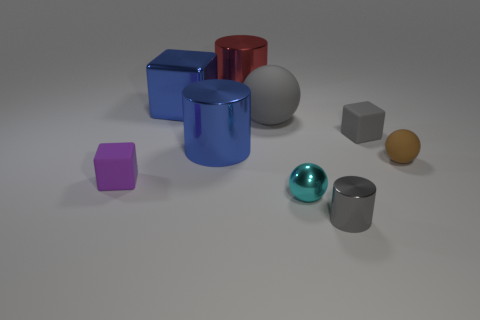Subtract all big blue cylinders. How many cylinders are left? 2 Add 1 purple shiny spheres. How many objects exist? 10 Subtract all spheres. How many objects are left? 6 Subtract all red balls. Subtract all cyan blocks. How many balls are left? 3 Add 5 gray cylinders. How many gray cylinders exist? 6 Subtract 1 blue cylinders. How many objects are left? 8 Subtract all green things. Subtract all brown spheres. How many objects are left? 8 Add 8 metal cubes. How many metal cubes are left? 9 